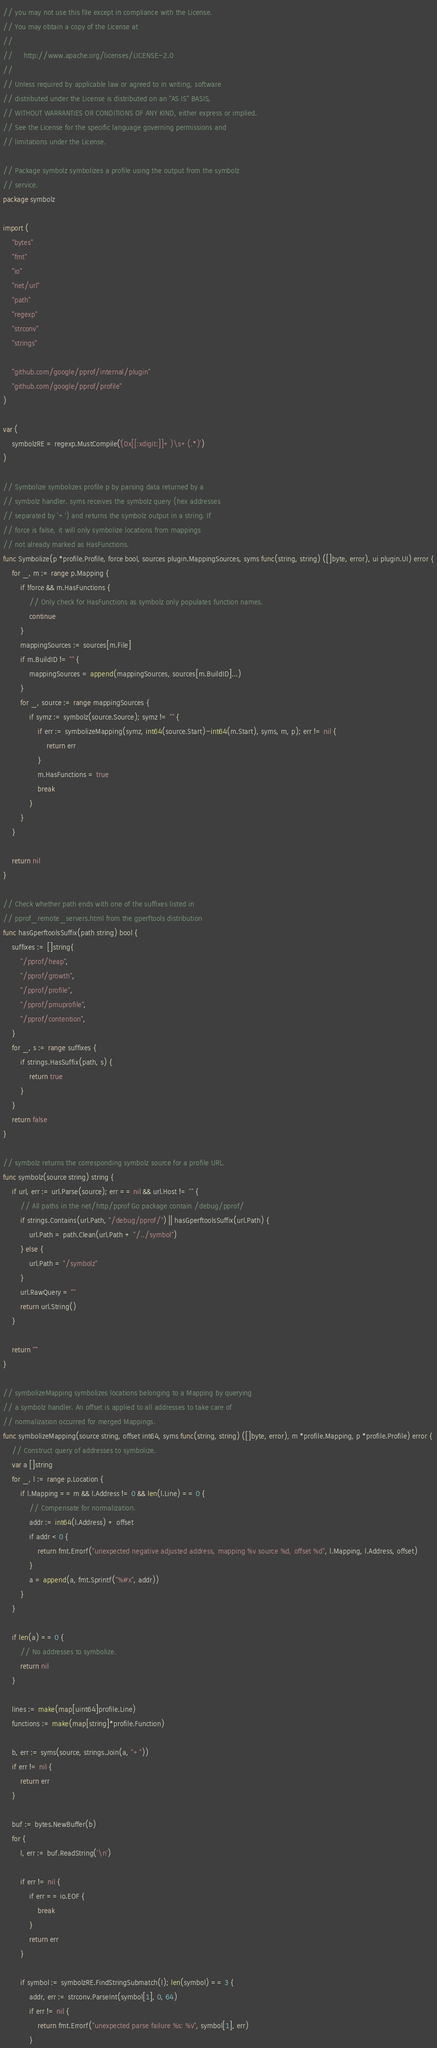Convert code to text. <code><loc_0><loc_0><loc_500><loc_500><_Go_>// you may not use this file except in compliance with the License.
// You may obtain a copy of the License at
//
//     http://www.apache.org/licenses/LICENSE-2.0
//
// Unless required by applicable law or agreed to in writing, software
// distributed under the License is distributed on an "AS IS" BASIS,
// WITHOUT WARRANTIES OR CONDITIONS OF ANY KIND, either express or implied.
// See the License for the specific language governing permissions and
// limitations under the License.

// Package symbolz symbolizes a profile using the output from the symbolz
// service.
package symbolz

import (
	"bytes"
	"fmt"
	"io"
	"net/url"
	"path"
	"regexp"
	"strconv"
	"strings"

	"github.com/google/pprof/internal/plugin"
	"github.com/google/pprof/profile"
)

var (
	symbolzRE = regexp.MustCompile(`(0x[[:xdigit:]]+)\s+(.*)`)
)

// Symbolize symbolizes profile p by parsing data returned by a
// symbolz handler. syms receives the symbolz query (hex addresses
// separated by '+') and returns the symbolz output in a string. If
// force is false, it will only symbolize locations from mappings
// not already marked as HasFunctions.
func Symbolize(p *profile.Profile, force bool, sources plugin.MappingSources, syms func(string, string) ([]byte, error), ui plugin.UI) error {
	for _, m := range p.Mapping {
		if !force && m.HasFunctions {
			// Only check for HasFunctions as symbolz only populates function names.
			continue
		}
		mappingSources := sources[m.File]
		if m.BuildID != "" {
			mappingSources = append(mappingSources, sources[m.BuildID]...)
		}
		for _, source := range mappingSources {
			if symz := symbolz(source.Source); symz != "" {
				if err := symbolizeMapping(symz, int64(source.Start)-int64(m.Start), syms, m, p); err != nil {
					return err
				}
				m.HasFunctions = true
				break
			}
		}
	}

	return nil
}

// Check whether path ends with one of the suffixes listed in
// pprof_remote_servers.html from the gperftools distribution
func hasGperftoolsSuffix(path string) bool {
	suffixes := []string{
		"/pprof/heap",
		"/pprof/growth",
		"/pprof/profile",
		"/pprof/pmuprofile",
		"/pprof/contention",
	}
	for _, s := range suffixes {
		if strings.HasSuffix(path, s) {
			return true
		}
	}
	return false
}

// symbolz returns the corresponding symbolz source for a profile URL.
func symbolz(source string) string {
	if url, err := url.Parse(source); err == nil && url.Host != "" {
		// All paths in the net/http/pprof Go package contain /debug/pprof/
		if strings.Contains(url.Path, "/debug/pprof/") || hasGperftoolsSuffix(url.Path) {
			url.Path = path.Clean(url.Path + "/../symbol")
		} else {
			url.Path = "/symbolz"
		}
		url.RawQuery = ""
		return url.String()
	}

	return ""
}

// symbolizeMapping symbolizes locations belonging to a Mapping by querying
// a symbolz handler. An offset is applied to all addresses to take care of
// normalization occurred for merged Mappings.
func symbolizeMapping(source string, offset int64, syms func(string, string) ([]byte, error), m *profile.Mapping, p *profile.Profile) error {
	// Construct query of addresses to symbolize.
	var a []string
	for _, l := range p.Location {
		if l.Mapping == m && l.Address != 0 && len(l.Line) == 0 {
			// Compensate for normalization.
			addr := int64(l.Address) + offset
			if addr < 0 {
				return fmt.Errorf("unexpected negative adjusted address, mapping %v source %d, offset %d", l.Mapping, l.Address, offset)
			}
			a = append(a, fmt.Sprintf("%#x", addr))
		}
	}

	if len(a) == 0 {
		// No addresses to symbolize.
		return nil
	}

	lines := make(map[uint64]profile.Line)
	functions := make(map[string]*profile.Function)

	b, err := syms(source, strings.Join(a, "+"))
	if err != nil {
		return err
	}

	buf := bytes.NewBuffer(b)
	for {
		l, err := buf.ReadString('\n')

		if err != nil {
			if err == io.EOF {
				break
			}
			return err
		}

		if symbol := symbolzRE.FindStringSubmatch(l); len(symbol) == 3 {
			addr, err := strconv.ParseInt(symbol[1], 0, 64)
			if err != nil {
				return fmt.Errorf("unexpected parse failure %s: %v", symbol[1], err)
			}</code> 